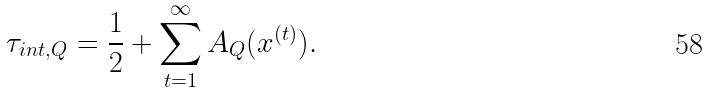<formula> <loc_0><loc_0><loc_500><loc_500>\tau _ { i n t , Q } = \frac { 1 } { 2 } + \sum _ { t = 1 } ^ { \infty } A _ { Q } ( x ^ { ( t ) } ) .</formula> 